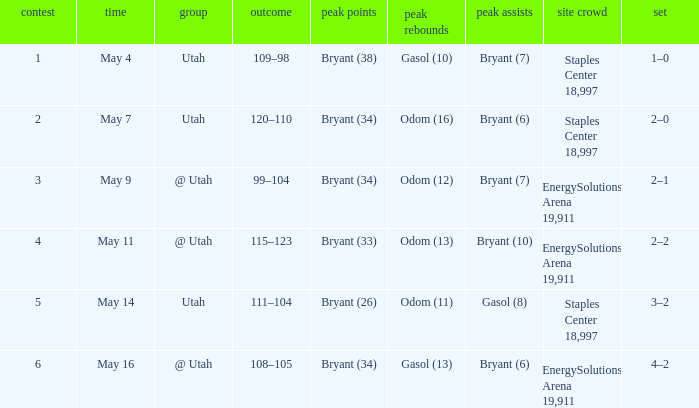What is the Series with a High rebounds with gasol (10)? 1–0. 